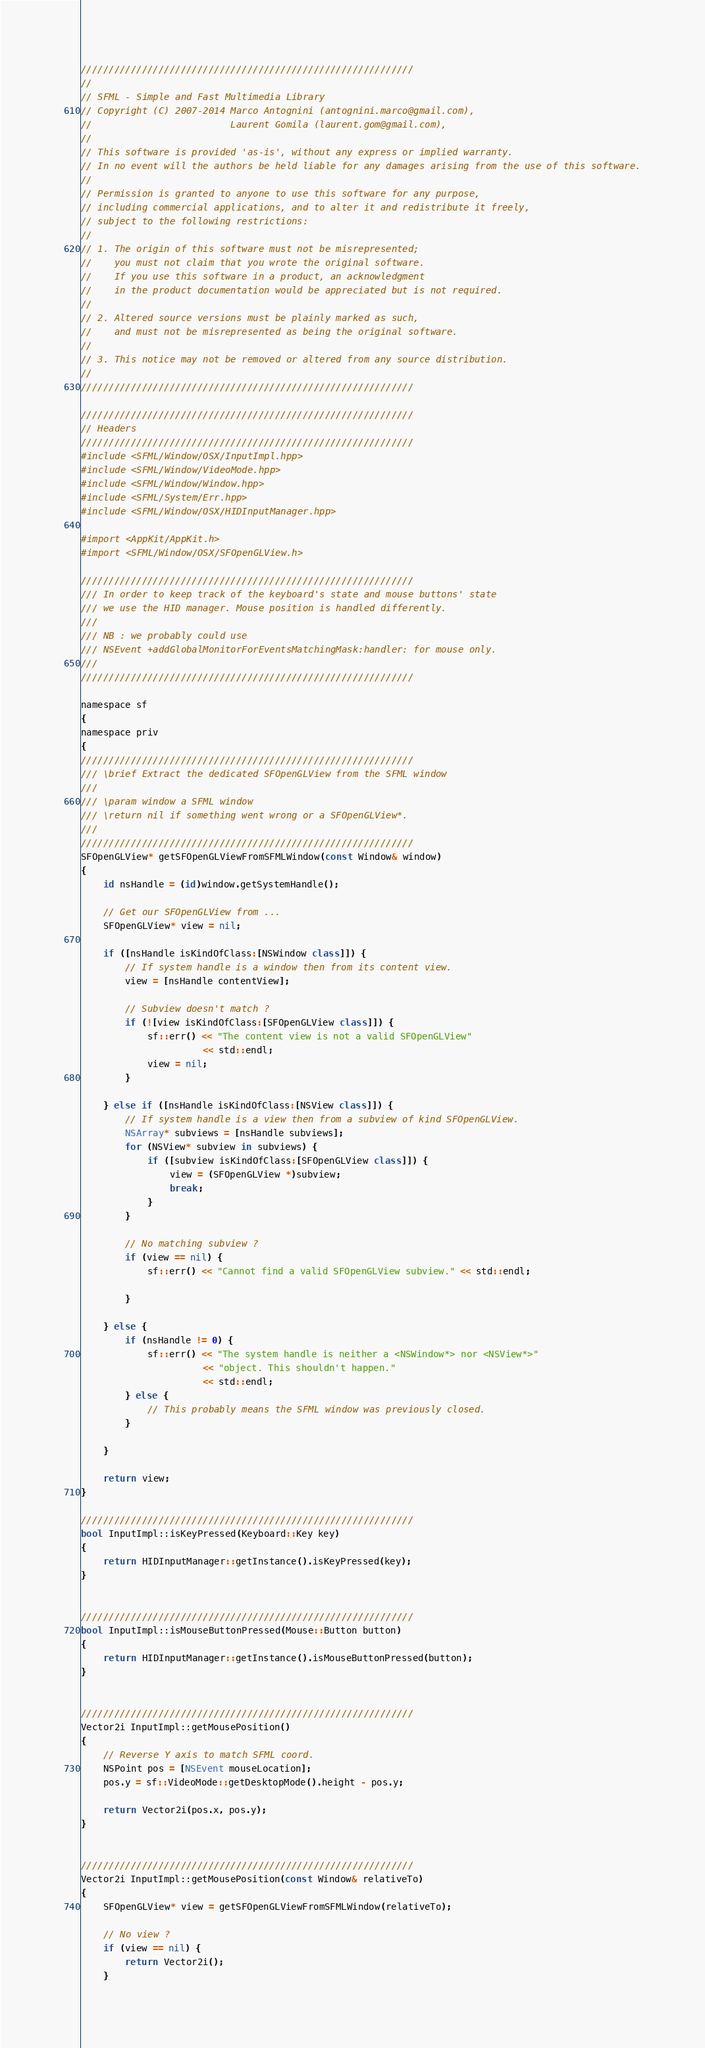Convert code to text. <code><loc_0><loc_0><loc_500><loc_500><_ObjectiveC_>////////////////////////////////////////////////////////////
//
// SFML - Simple and Fast Multimedia Library
// Copyright (C) 2007-2014 Marco Antognini (antognini.marco@gmail.com),
//                         Laurent Gomila (laurent.gom@gmail.com),
//
// This software is provided 'as-is', without any express or implied warranty.
// In no event will the authors be held liable for any damages arising from the use of this software.
//
// Permission is granted to anyone to use this software for any purpose,
// including commercial applications, and to alter it and redistribute it freely,
// subject to the following restrictions:
//
// 1. The origin of this software must not be misrepresented;
//    you must not claim that you wrote the original software.
//    If you use this software in a product, an acknowledgment
//    in the product documentation would be appreciated but is not required.
//
// 2. Altered source versions must be plainly marked as such,
//    and must not be misrepresented as being the original software.
//
// 3. This notice may not be removed or altered from any source distribution.
//
////////////////////////////////////////////////////////////

////////////////////////////////////////////////////////////
// Headers
////////////////////////////////////////////////////////////
#include <SFML/Window/OSX/InputImpl.hpp>
#include <SFML/Window/VideoMode.hpp>
#include <SFML/Window/Window.hpp>
#include <SFML/System/Err.hpp>
#include <SFML/Window/OSX/HIDInputManager.hpp>

#import <AppKit/AppKit.h>
#import <SFML/Window/OSX/SFOpenGLView.h>

////////////////////////////////////////////////////////////
/// In order to keep track of the keyboard's state and mouse buttons' state
/// we use the HID manager. Mouse position is handled differently.
///
/// NB : we probably could use
/// NSEvent +addGlobalMonitorForEventsMatchingMask:handler: for mouse only.
///
////////////////////////////////////////////////////////////

namespace sf
{
namespace priv
{
////////////////////////////////////////////////////////////
/// \brief Extract the dedicated SFOpenGLView from the SFML window
///
/// \param window a SFML window
/// \return nil if something went wrong or a SFOpenGLView*.
///
////////////////////////////////////////////////////////////
SFOpenGLView* getSFOpenGLViewFromSFMLWindow(const Window& window)
{
    id nsHandle = (id)window.getSystemHandle();

    // Get our SFOpenGLView from ...
    SFOpenGLView* view = nil;

    if ([nsHandle isKindOfClass:[NSWindow class]]) {
        // If system handle is a window then from its content view.
        view = [nsHandle contentView];

        // Subview doesn't match ?
        if (![view isKindOfClass:[SFOpenGLView class]]) {
            sf::err() << "The content view is not a valid SFOpenGLView"
                      << std::endl;
            view = nil;
        }

    } else if ([nsHandle isKindOfClass:[NSView class]]) {
        // If system handle is a view then from a subview of kind SFOpenGLView.
        NSArray* subviews = [nsHandle subviews];
        for (NSView* subview in subviews) {
            if ([subview isKindOfClass:[SFOpenGLView class]]) {
                view = (SFOpenGLView *)subview;
                break;
            }
        }

        // No matching subview ?
        if (view == nil) {
            sf::err() << "Cannot find a valid SFOpenGLView subview." << std::endl;

        }

    } else {
        if (nsHandle != 0) {
            sf::err() << "The system handle is neither a <NSWindow*> nor <NSView*>"
                      << "object. This shouldn't happen."
                      << std::endl;
        } else {
            // This probably means the SFML window was previously closed.
        }

    }

    return view;
}

////////////////////////////////////////////////////////////
bool InputImpl::isKeyPressed(Keyboard::Key key)
{
    return HIDInputManager::getInstance().isKeyPressed(key);
}


////////////////////////////////////////////////////////////
bool InputImpl::isMouseButtonPressed(Mouse::Button button)
{
    return HIDInputManager::getInstance().isMouseButtonPressed(button);
}


////////////////////////////////////////////////////////////
Vector2i InputImpl::getMousePosition()
{
    // Reverse Y axis to match SFML coord.
    NSPoint pos = [NSEvent mouseLocation];
    pos.y = sf::VideoMode::getDesktopMode().height - pos.y;

    return Vector2i(pos.x, pos.y);
}


////////////////////////////////////////////////////////////
Vector2i InputImpl::getMousePosition(const Window& relativeTo)
{
    SFOpenGLView* view = getSFOpenGLViewFromSFMLWindow(relativeTo);

    // No view ?
    if (view == nil) {
        return Vector2i();
    }
</code> 